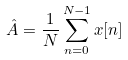Convert formula to latex. <formula><loc_0><loc_0><loc_500><loc_500>\hat { A } = \frac { 1 } { N } \sum _ { n = 0 } ^ { N - 1 } x [ n ]</formula> 